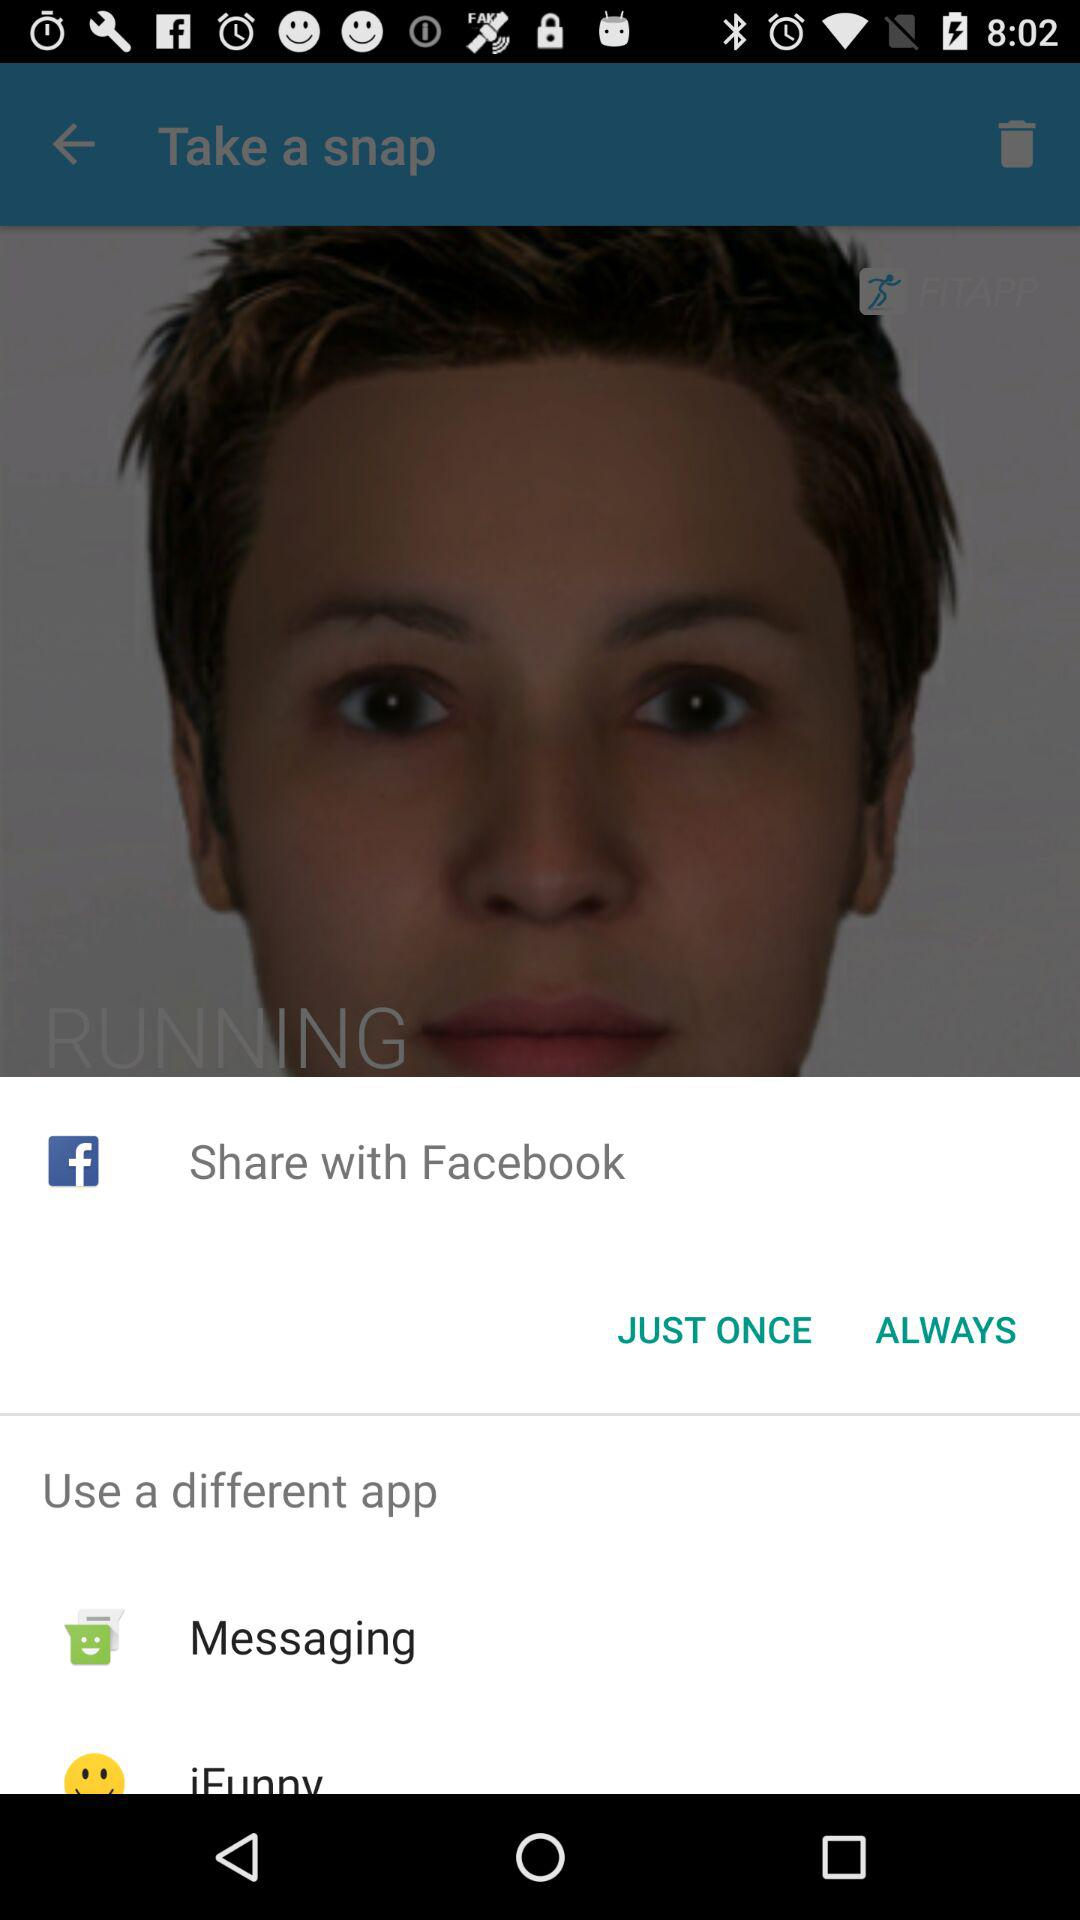What application can I use to share? You can share it with "Facebook". 